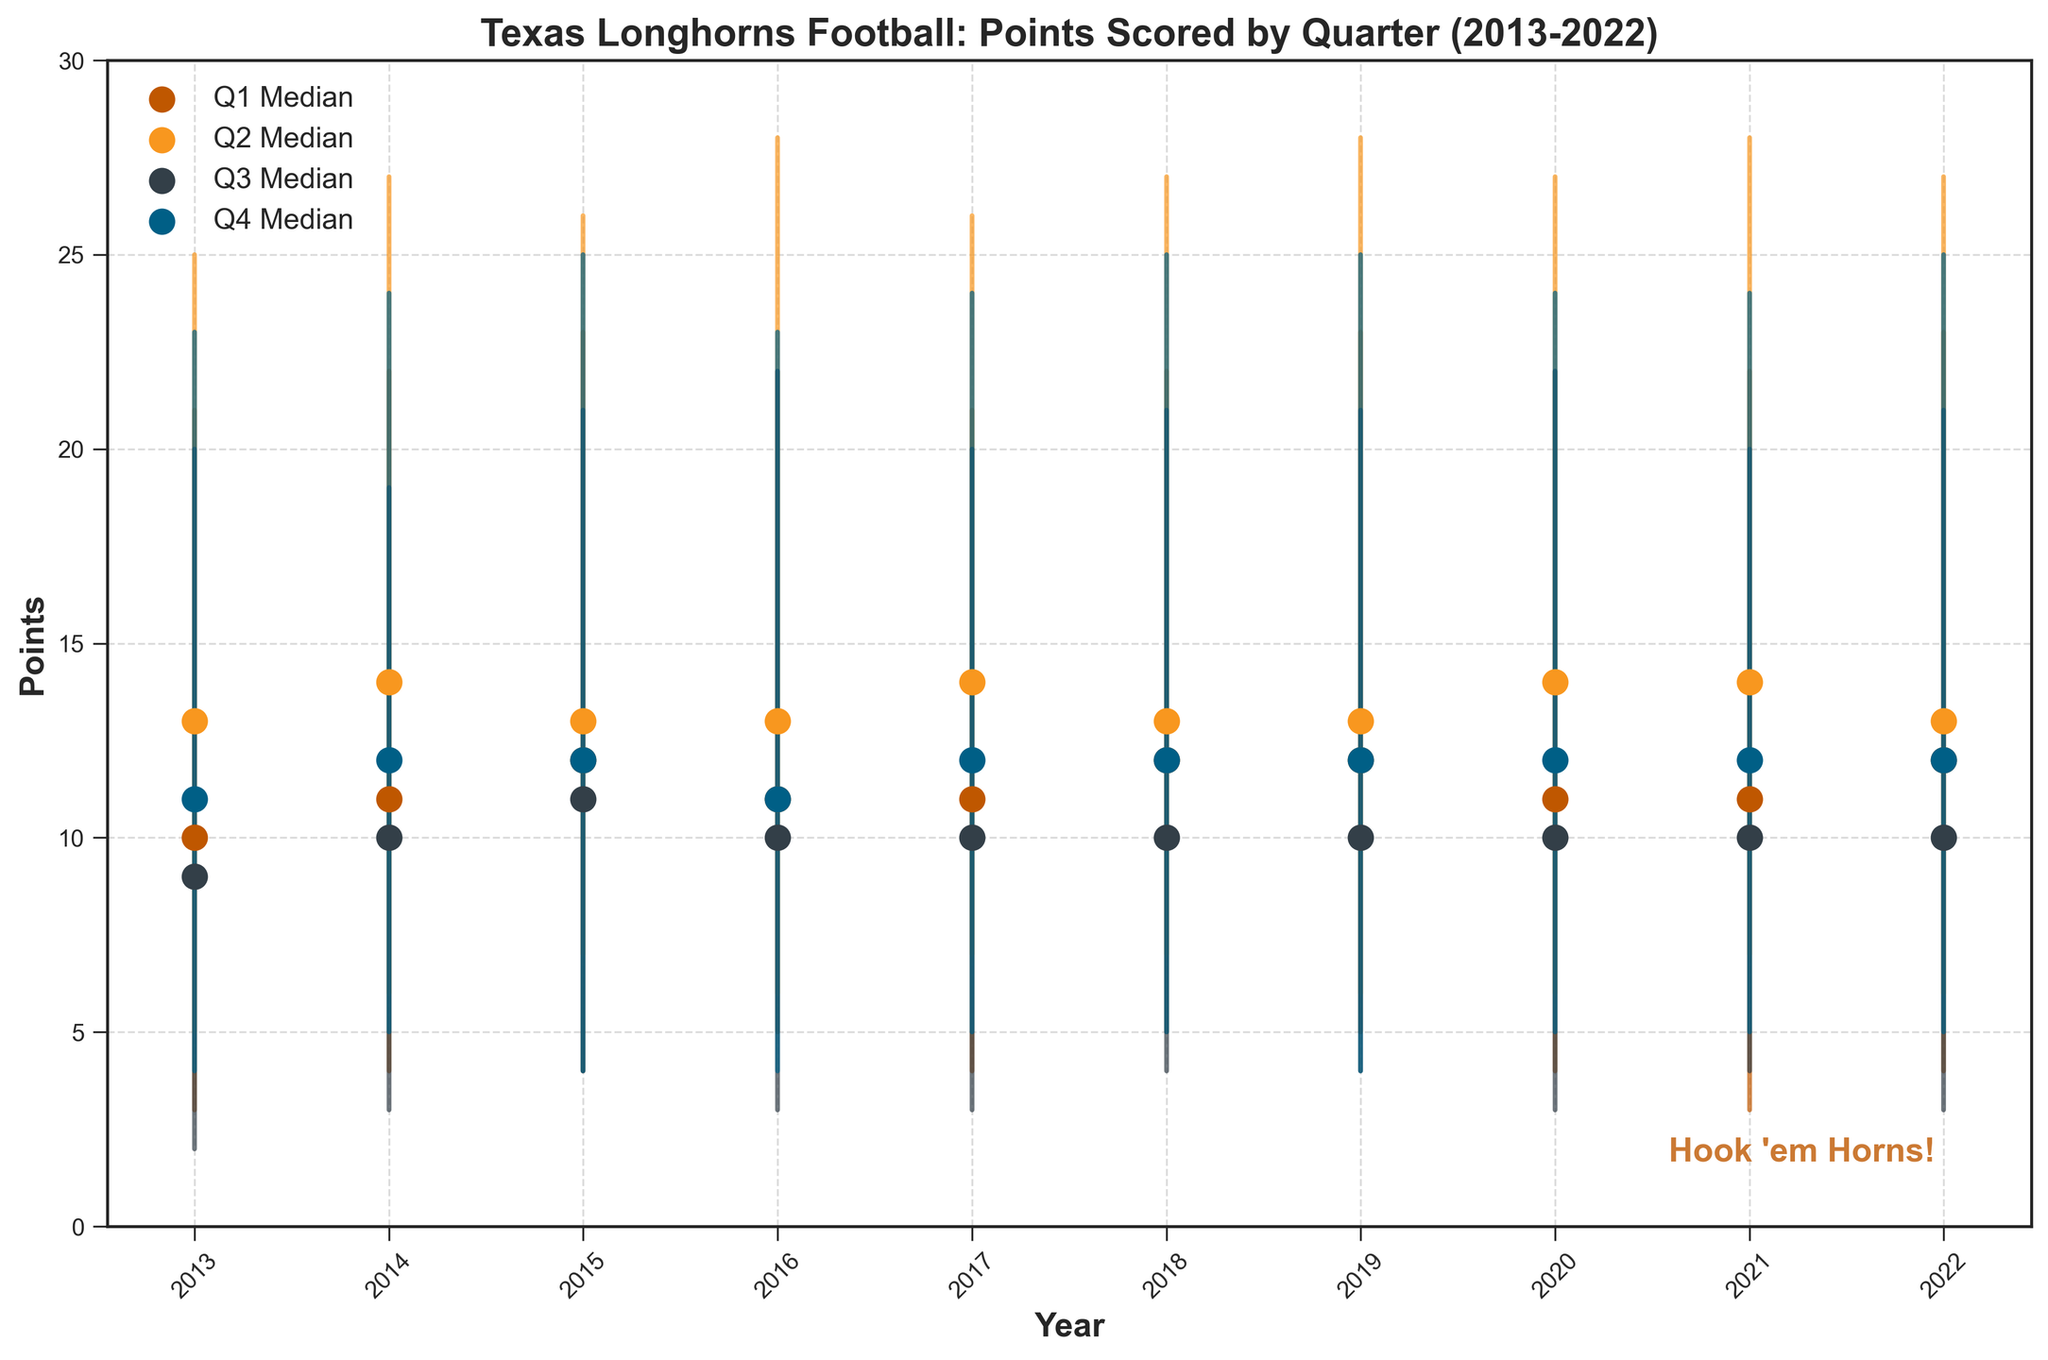What is the title of the figure? The title of the figure is positioned at the top and is usually the most prominent text. It reads as 'Texas Longhorns Football: Points Scored by Quarter (2013-2022)'.
Answer: Texas Longhorns Football: Points Scored by Quarter (2013-2022) What color represents the 2nd quarter (Q2) data points? The colors of the different quarters are distinguished in the plot legend on the upper left. The 2nd quarter (Q2) data points are orange.
Answer: Orange For which year is the median point of Q4 the highest? To answer this, look at the highest median point for Q4's data points on the vertical position and check the corresponding year on the horizontal axis. The highest median point for Q4 is in 2020.
Answer: 2020 What are the minimum and maximum points scored in the second quarter of 2021? Identify the interval line for Q2 in 2021. The lower bound of the line is the minimum, and the upper bound is the maximum. For Q2 in 2021, the min point is 7 and the max point is 28.
Answer: Min: 7, Max: 28 Which quarter has the most significant variation in points scored in 2016? Variation is the range between min and max points. Compare the lengths of the vertical lines for each quarter in 2016. Q2 has the most significant variation with 6 to 28 points.
Answer: Q2 How did the median points scored in the third quarter change from 2013 to 2022? Check the median points' scatter plot for Q3 in 2013 and compare it to Q3 in 2022. The median point for Q3 in 2013 is 9, and for 2022 it is 10, indicating a slight increase.
Answer: Increased by 1 Which quarter has the consistently highest median points across the decade (2013-2022)? Look at the median points for each quarter over the entire period. Q2 consistently has the highest median points compared to other quarters.
Answer: Q2 What is the average of the median points scored in the first quarter (Q1) over the decade? Sum the median points of Q1 for each year from 2013 to 2022 (10, 11, 12, 11, 11, 12, 11, 12, 12, 11) and divide by the number of years (10). (10+11+12+11+11+12+11+12+12+11) / 10 = 11.3
Answer: 11.3 Which year had the closest median points between Q1 and Q4? Look at the Q1 and Q4 median points for each year. 2020 where Q1's median is 11 and Q4's median is 12 has the smallest difference of 1 point.
Answer: 2020 